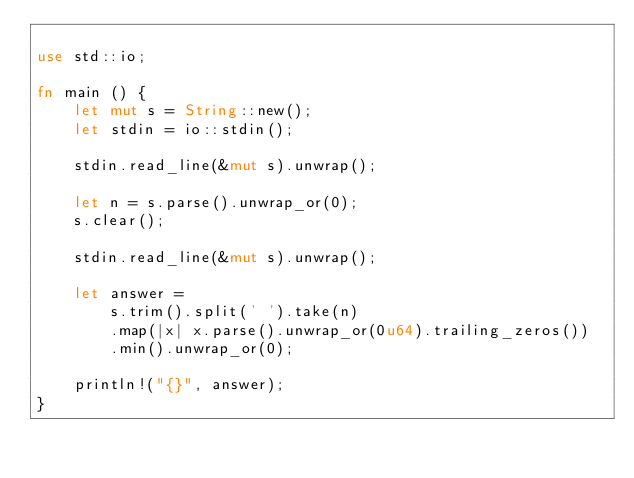Convert code to text. <code><loc_0><loc_0><loc_500><loc_500><_Rust_>
use std::io;

fn main () {
    let mut s = String::new();
    let stdin = io::stdin();

    stdin.read_line(&mut s).unwrap();

    let n = s.parse().unwrap_or(0);
    s.clear();

    stdin.read_line(&mut s).unwrap();

    let answer =
        s.trim().split(' ').take(n)
        .map(|x| x.parse().unwrap_or(0u64).trailing_zeros())
        .min().unwrap_or(0);

    println!("{}", answer);
}</code> 